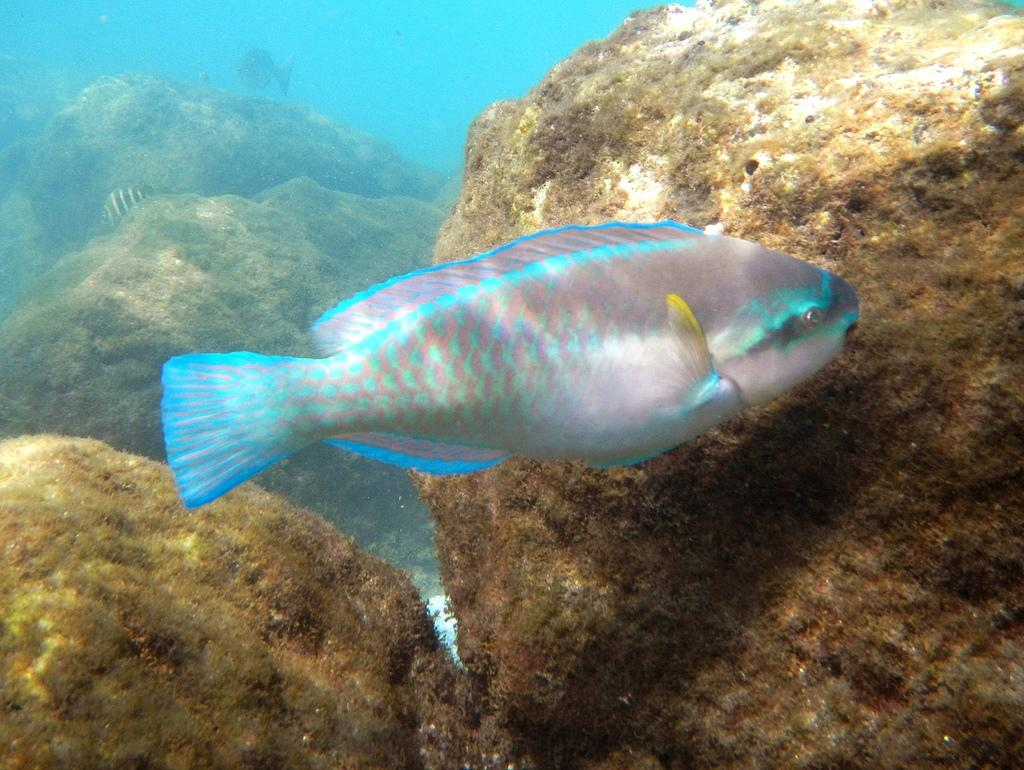Where was the image taken? The image is taken in the water. What can be seen swimming in the water? There are fishes swimming in the water. What type of objects are visible in the background? There are stones in the background of the image. What kind of vegetation is present on the stones? Aquatic plants are present on the stones. What direction is the current flowing in the image? There is no reference to a current in the image, as it is focused on fishes swimming in the water and the surrounding environment. --- Facts: 1. There is a person sitting on a bench. 2. The person is reading a book. 3. There is a tree behind the bench. 4. The sky is visible in the image. Absurd Topics: parrot, bicycle, sand Conversation: What is the person in the image doing? The person is sitting on a bench. What activity is the person engaged in while sitting on the bench? The person is reading a book. What can be seen behind the bench in the image? There is a tree behind the bench. What is visible at the top of the image? The sky is visible in the image. Reasoning: Let's think step by step in order to produce the conversation. We start by identifying the main subject in the image, which is the person sitting on the bench. Then, we expand the conversation to include the activity the person is engaged in, which is reading a book. Next, we focus on the background elements, mentioning the tree behind the bench. Finally, we provide information about the sky visible in the image. Absurd Question/Answer: Can you tell me how many parrots are sitting on the bicycle in the image? There are no parrots or bicycles present in the image; it features a person sitting on a bench and reading a book. 